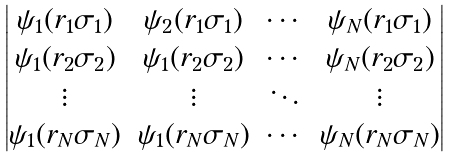Convert formula to latex. <formula><loc_0><loc_0><loc_500><loc_500>\begin{vmatrix} \psi _ { 1 } ( { r } _ { 1 } \sigma _ { 1 } ) & \psi _ { 2 } ( { r } _ { 1 } \sigma _ { 1 } ) & \cdots & \psi _ { N } ( { r } _ { 1 } \sigma _ { 1 } ) \\ \psi _ { 1 } ( { r } _ { 2 } \sigma _ { 2 } ) & \psi _ { 1 } ( { r } _ { 2 } \sigma _ { 2 } ) & \cdots & \psi _ { N } ( { r } _ { 2 } \sigma _ { 2 } ) \\ \vdots & \vdots & \ddots & \vdots \\ \psi _ { 1 } ( { r } _ { N } \sigma _ { N } ) & \psi _ { 1 } ( { r } _ { N } \sigma _ { N } ) & \cdots & \psi _ { N } ( { r } _ { N } \sigma _ { N } ) \\ \end{vmatrix}</formula> 